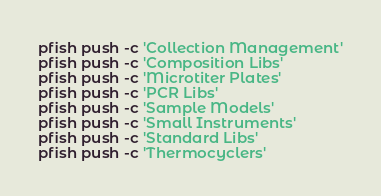<code> <loc_0><loc_0><loc_500><loc_500><_Bash_>pfish push -c 'Collection Management'
pfish push -c 'Composition Libs'
pfish push -c 'Microtiter Plates'
pfish push -c 'PCR Libs'
pfish push -c 'Sample Models'
pfish push -c 'Small Instruments'
pfish push -c 'Standard Libs'
pfish push -c 'Thermocyclers'</code> 